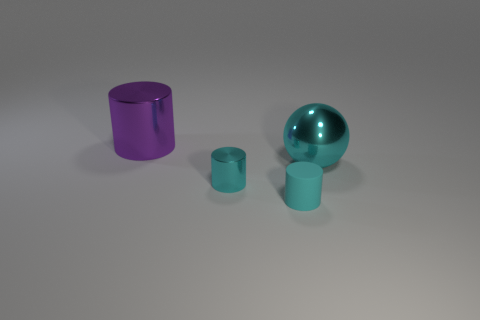What shape is the big object that is the same color as the small metallic object?
Make the answer very short. Sphere. What color is the object left of the tiny cylinder to the left of the small cyan matte object?
Make the answer very short. Purple. Is the color of the object that is right of the tiny cyan rubber cylinder the same as the tiny metallic cylinder?
Offer a terse response. Yes. What is the shape of the big thing that is to the left of the cyan thing on the right side of the cyan rubber thing to the right of the small cyan metal thing?
Keep it short and to the point. Cylinder. How many small cylinders are on the right side of the cyan shiny cylinder that is to the left of the tiny cyan matte object?
Provide a short and direct response. 1. Does the large cyan object have the same material as the big cylinder?
Ensure brevity in your answer.  Yes. There is a cyan metallic object on the left side of the big metal object in front of the purple metallic thing; what number of cyan things are in front of it?
Your answer should be compact. 1. What is the color of the cylinder behind the big cyan sphere?
Ensure brevity in your answer.  Purple. There is a metallic thing behind the cyan metallic thing that is right of the small cyan matte cylinder; what shape is it?
Provide a short and direct response. Cylinder. Do the big sphere and the big metallic cylinder have the same color?
Your answer should be very brief. No. 